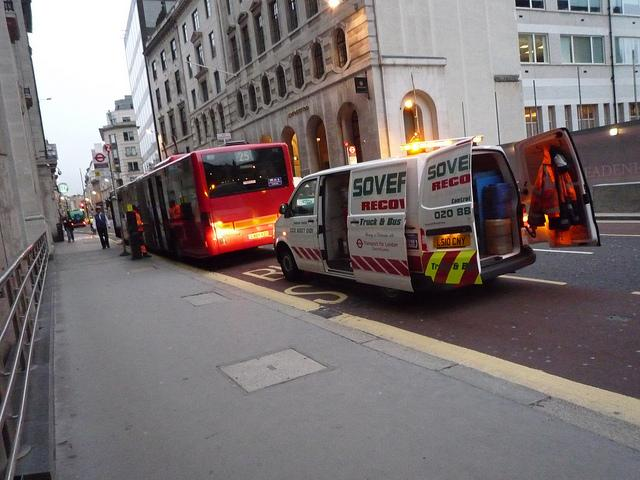Why is the red vehicle stopped here?

Choices:
A) protest
B) sales trick
C) boarding passengers
D) accident boarding passengers 